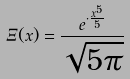Convert formula to latex. <formula><loc_0><loc_0><loc_500><loc_500>\Xi ( x ) = \frac { e ^ { \cdot \frac { x ^ { 5 } } { 5 } } } { \sqrt { 5 \pi } }</formula> 